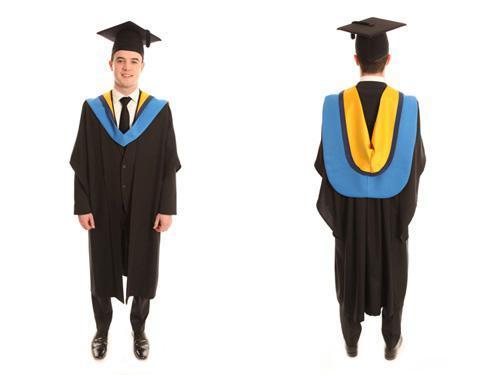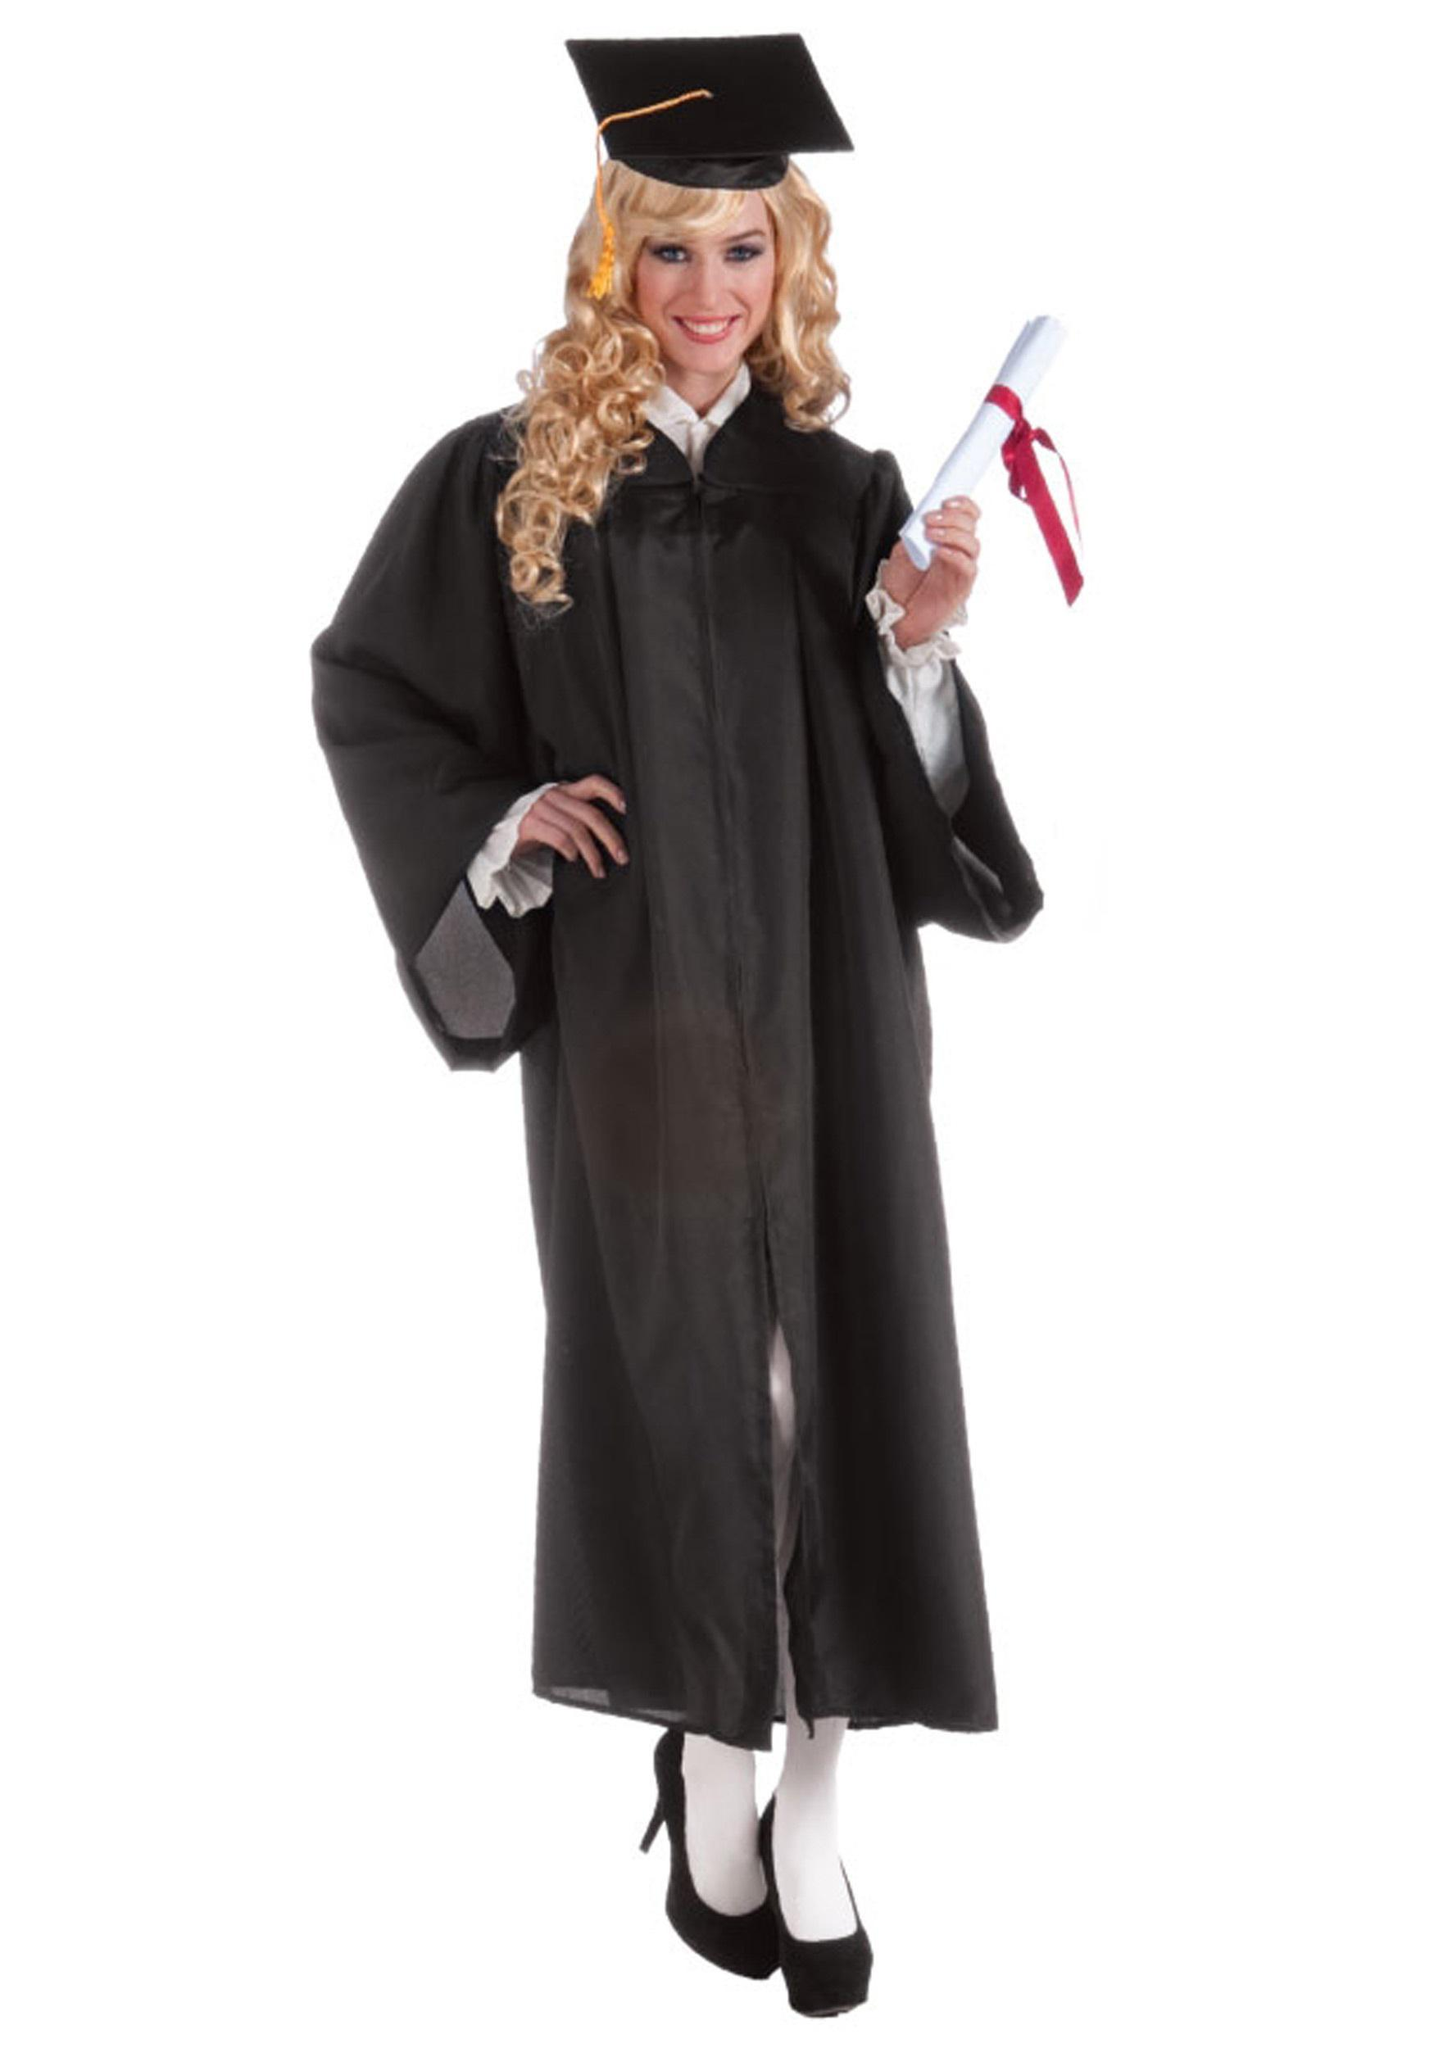The first image is the image on the left, the second image is the image on the right. For the images displayed, is the sentence "THere are exactly two people in the image on the left." factually correct? Answer yes or no. Yes. 